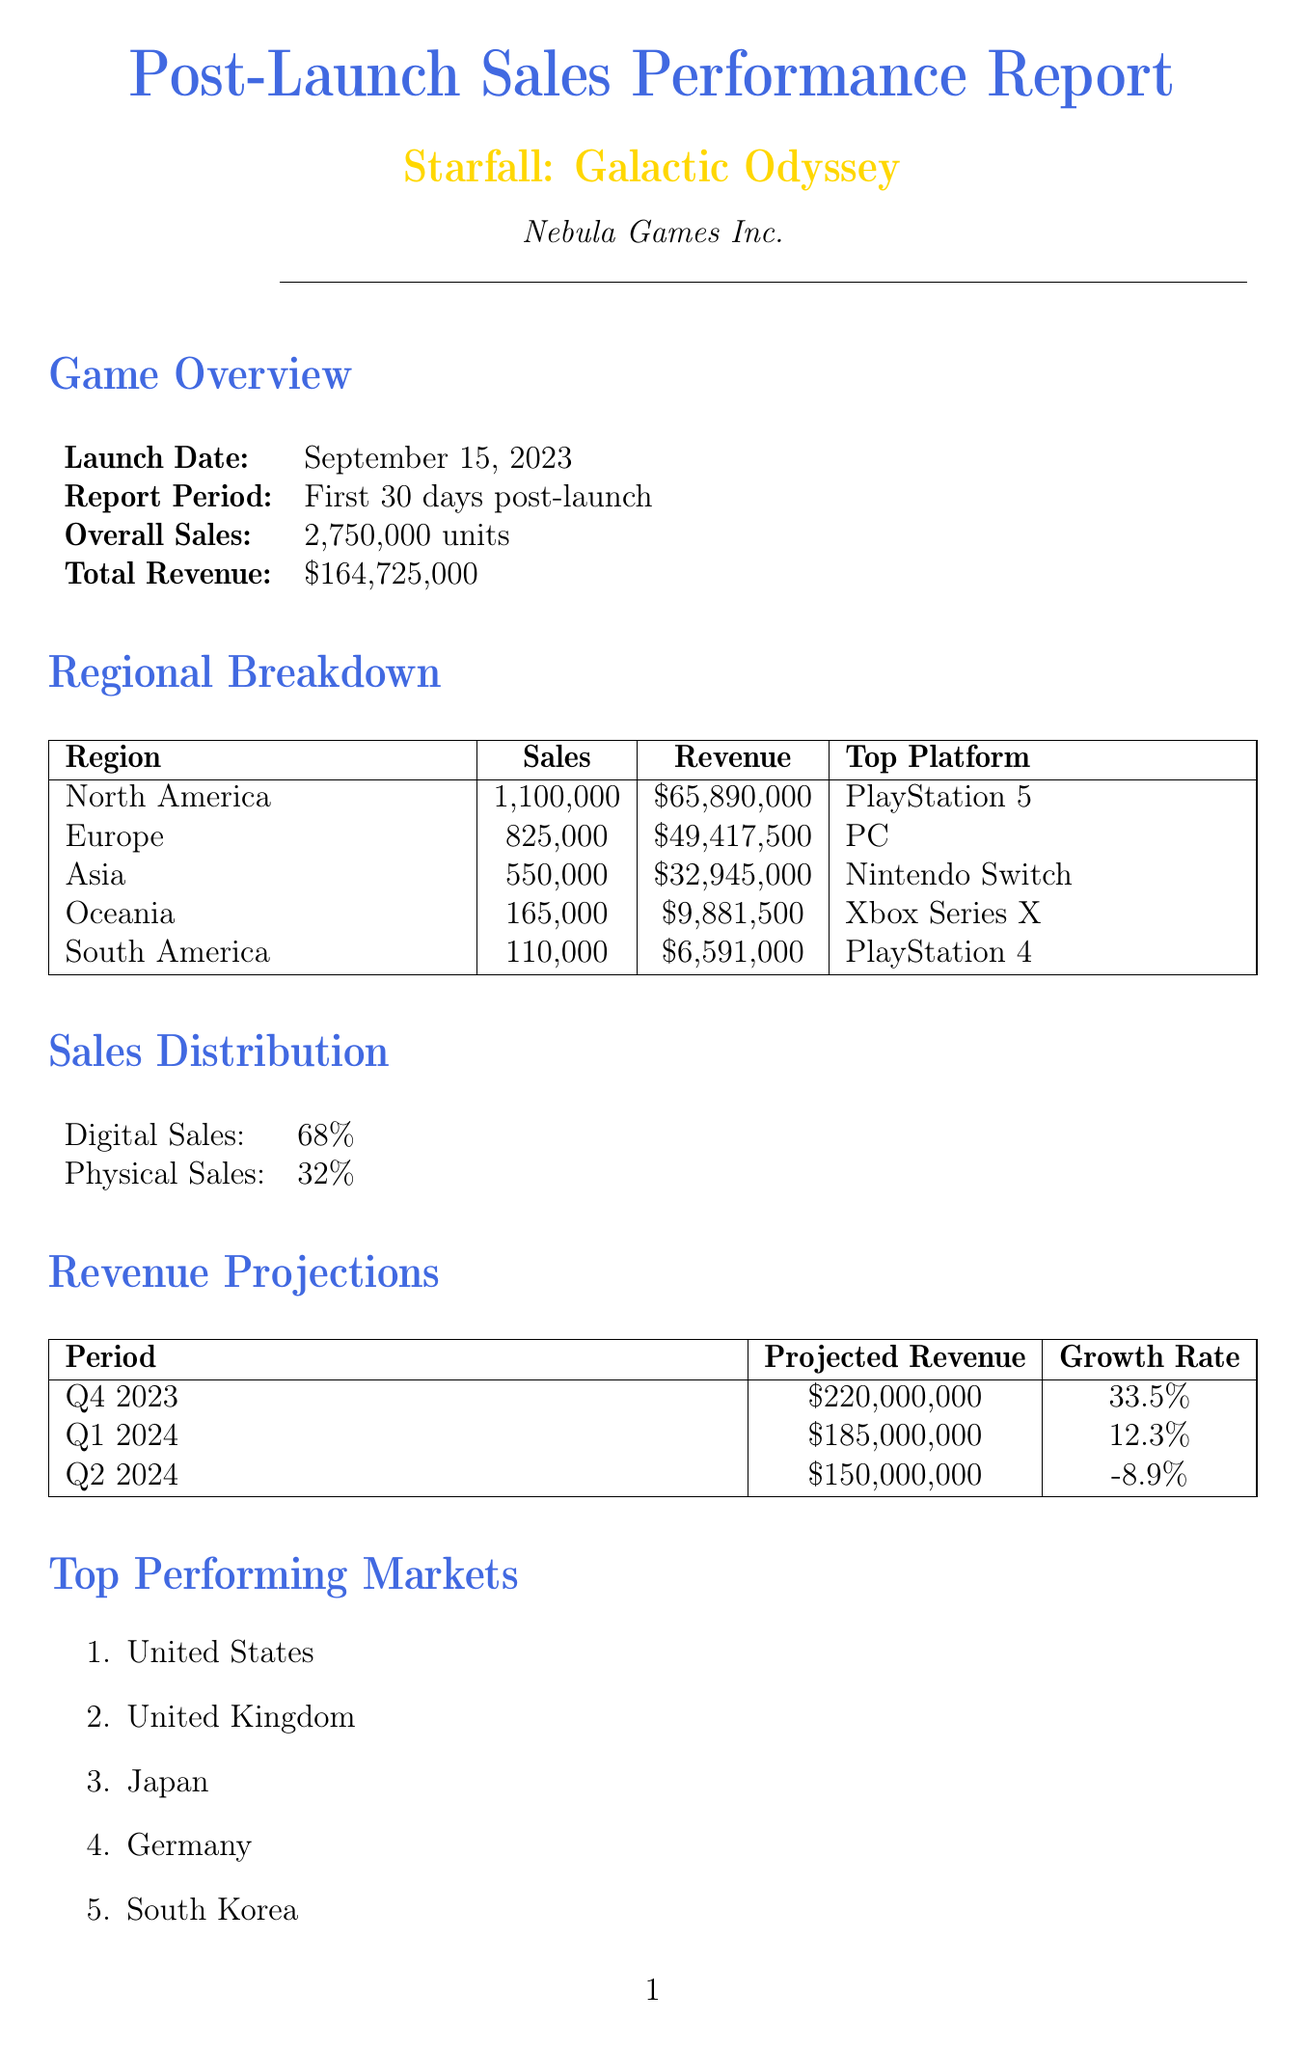What is the launch date of the game? The launch date is explicitly mentioned in the document as September 15, 2023.
Answer: September 15, 2023 What is the total revenue generated in the first 30 days post-launch? The total revenue reported for the first 30 days is stated clearly in the document.
Answer: $164,725,000 Which region had the highest sales? The regional breakdown indicates that North America had the highest sales figure.
Answer: North America What percentage of sales were digital? The document provides the distribution of sales between digital and physical formats, specifying the percentage of digital sales.
Answer: 68% What is the projected revenue for Q4 2023? The revenue projections table includes the projected revenue for Q4 2023.
Answer: $220,000,000 Which marketing channel had the highest ROI? The marketing channel performance section showcases the ROI for different channels, revealing which had the highest ROI.
Answer: Social Media What are the top praised features mentioned by users? The user feedback section lists specific features that received high praise from players.
Answer: Immersive storyline, Graphics quality, Character customization What is the average rating of the game? The user feedback section states the average rating out of 5.
Answer: 4.7 When is the projected release date for the "Nebula Expansion" DLC? The DLC plans include the projected release date for the "Nebula Expansion."
Answer: December 1, 2023 